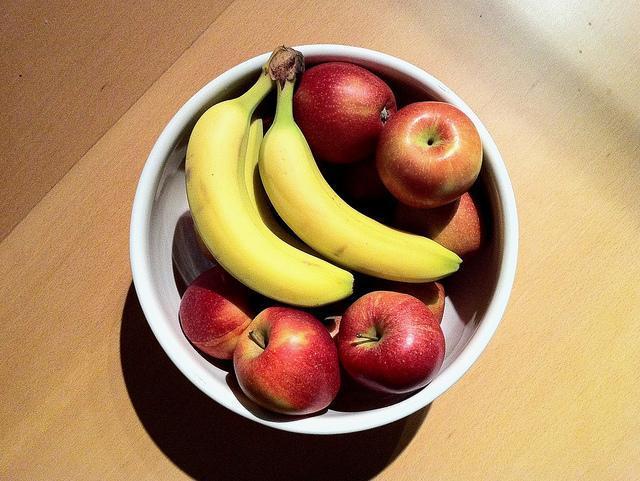How many different vegetables are in the bowl?
Give a very brief answer. 2. How many bananas are in this bowl?
Give a very brief answer. 3. How many pie ingredients are shown?
Give a very brief answer. 2. How many apples are visible?
Give a very brief answer. 6. 